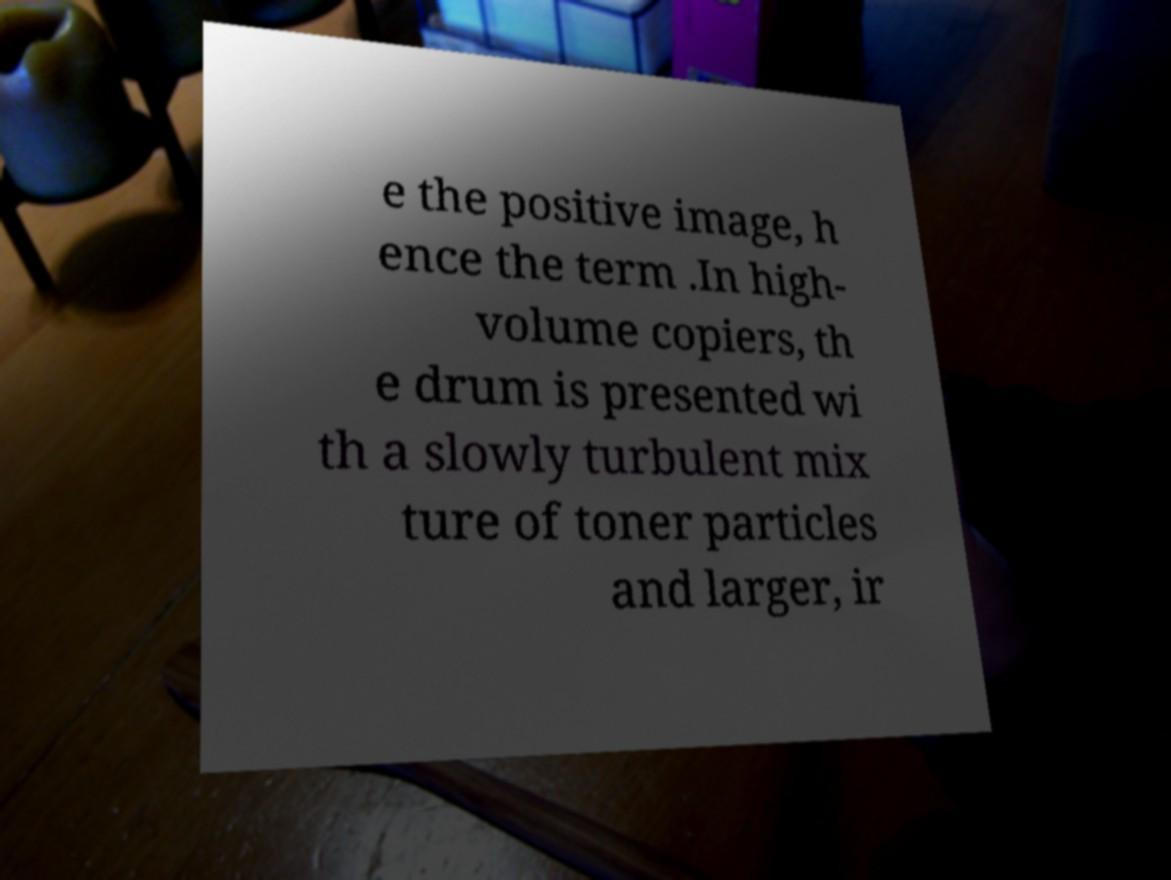Can you read and provide the text displayed in the image?This photo seems to have some interesting text. Can you extract and type it out for me? e the positive image, h ence the term .In high- volume copiers, th e drum is presented wi th a slowly turbulent mix ture of toner particles and larger, ir 